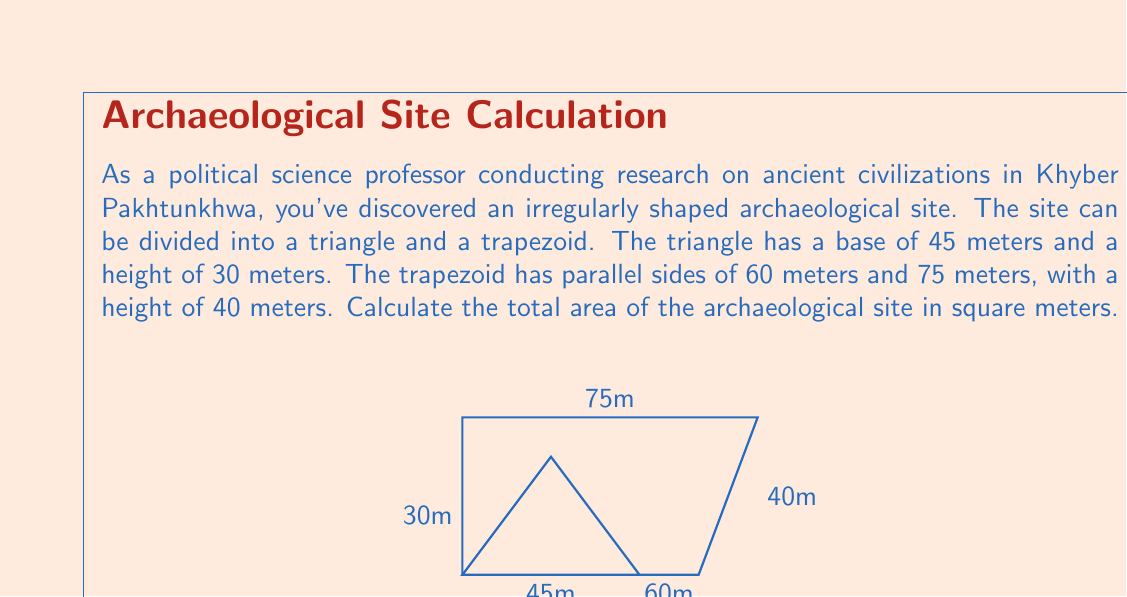Give your solution to this math problem. To solve this problem, we need to calculate the areas of the triangle and trapezoid separately, then add them together.

1. Area of the triangle:
   The formula for the area of a triangle is $A = \frac{1}{2} \times base \times height$
   $$A_{triangle} = \frac{1}{2} \times 45 \times 30 = 675 \text{ m}^2$$

2. Area of the trapezoid:
   The formula for the area of a trapezoid is $A = \frac{1}{2}(a+b)h$, where $a$ and $b$ are the parallel sides and $h$ is the height.
   $$A_{trapezoid} = \frac{1}{2}(60+75) \times 40 = \frac{1}{2} \times 135 \times 40 = 2700 \text{ m}^2$$

3. Total area:
   The total area is the sum of the triangle and trapezoid areas.
   $$A_{total} = A_{triangle} + A_{trapezoid} = 675 + 2700 = 3375 \text{ m}^2$$

Therefore, the total area of the archaeological site is 3375 square meters.
Answer: 3375 m² 